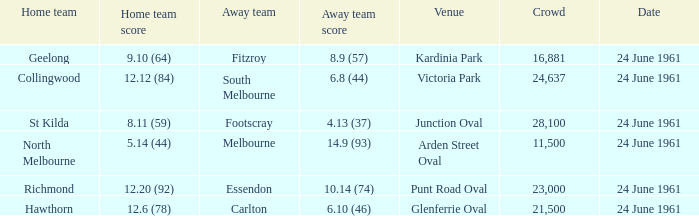What was the home team's score at the game attended by more than 24,637? 8.11 (59). 